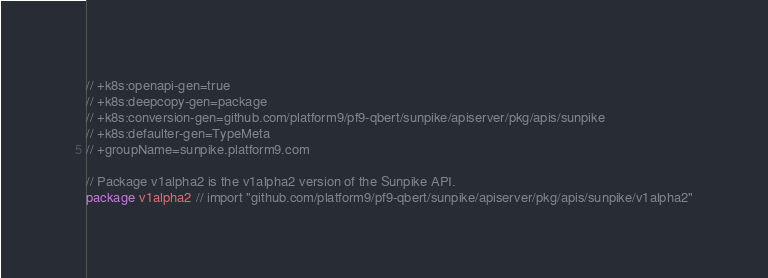<code> <loc_0><loc_0><loc_500><loc_500><_Go_>// +k8s:openapi-gen=true
// +k8s:deepcopy-gen=package
// +k8s:conversion-gen=github.com/platform9/pf9-qbert/sunpike/apiserver/pkg/apis/sunpike
// +k8s:defaulter-gen=TypeMeta
// +groupName=sunpike.platform9.com

// Package v1alpha2 is the v1alpha2 version of the Sunpike API.
package v1alpha2 // import "github.com/platform9/pf9-qbert/sunpike/apiserver/pkg/apis/sunpike/v1alpha2"
</code> 